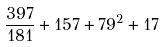<formula> <loc_0><loc_0><loc_500><loc_500>\frac { 3 9 7 } { 1 8 1 } + 1 5 7 + 7 9 ^ { 2 } + 1 7</formula> 